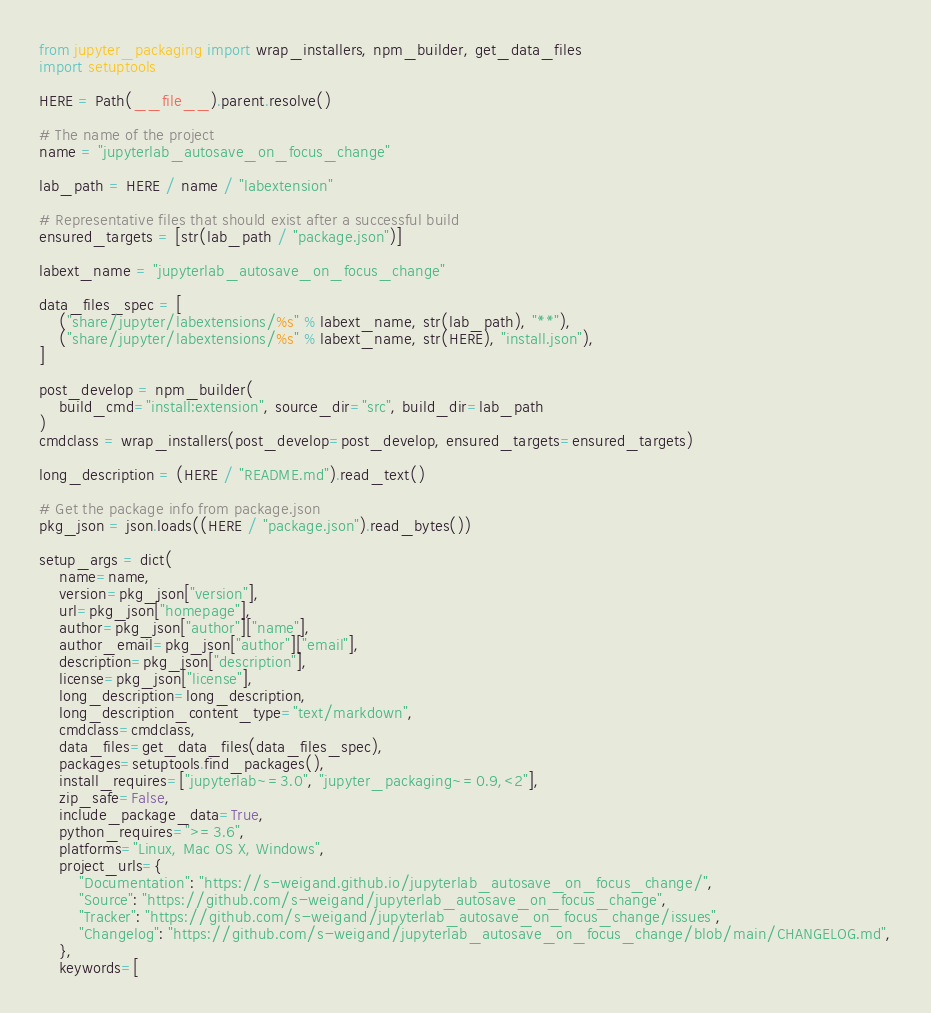<code> <loc_0><loc_0><loc_500><loc_500><_Python_>
from jupyter_packaging import wrap_installers, npm_builder, get_data_files
import setuptools

HERE = Path(__file__).parent.resolve()

# The name of the project
name = "jupyterlab_autosave_on_focus_change"

lab_path = HERE / name / "labextension"

# Representative files that should exist after a successful build
ensured_targets = [str(lab_path / "package.json")]

labext_name = "jupyterlab_autosave_on_focus_change"

data_files_spec = [
    ("share/jupyter/labextensions/%s" % labext_name, str(lab_path), "**"),
    ("share/jupyter/labextensions/%s" % labext_name, str(HERE), "install.json"),
]

post_develop = npm_builder(
    build_cmd="install:extension", source_dir="src", build_dir=lab_path
)
cmdclass = wrap_installers(post_develop=post_develop, ensured_targets=ensured_targets)

long_description = (HERE / "README.md").read_text()

# Get the package info from package.json
pkg_json = json.loads((HERE / "package.json").read_bytes())

setup_args = dict(
    name=name,
    version=pkg_json["version"],
    url=pkg_json["homepage"],
    author=pkg_json["author"]["name"],
    author_email=pkg_json["author"]["email"],
    description=pkg_json["description"],
    license=pkg_json["license"],
    long_description=long_description,
    long_description_content_type="text/markdown",
    cmdclass=cmdclass,
    data_files=get_data_files(data_files_spec),
    packages=setuptools.find_packages(),
    install_requires=["jupyterlab~=3.0", "jupyter_packaging~=0.9,<2"],
    zip_safe=False,
    include_package_data=True,
    python_requires=">=3.6",
    platforms="Linux, Mac OS X, Windows",
    project_urls={
        "Documentation": "https://s-weigand.github.io/jupyterlab_autosave_on_focus_change/",
        "Source": "https://github.com/s-weigand/jupyterlab_autosave_on_focus_change",
        "Tracker": "https://github.com/s-weigand/jupyterlab_autosave_on_focus_change/issues",
        "Changelog": "https://github.com/s-weigand/jupyterlab_autosave_on_focus_change/blob/main/CHANGELOG.md",
    },
    keywords=[</code> 